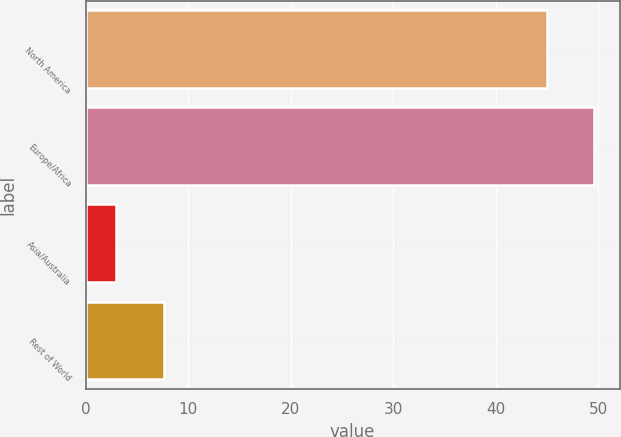Convert chart. <chart><loc_0><loc_0><loc_500><loc_500><bar_chart><fcel>North America<fcel>Europe/Africa<fcel>Asia/Australia<fcel>Rest of World<nl><fcel>45<fcel>49.6<fcel>3<fcel>7.6<nl></chart> 